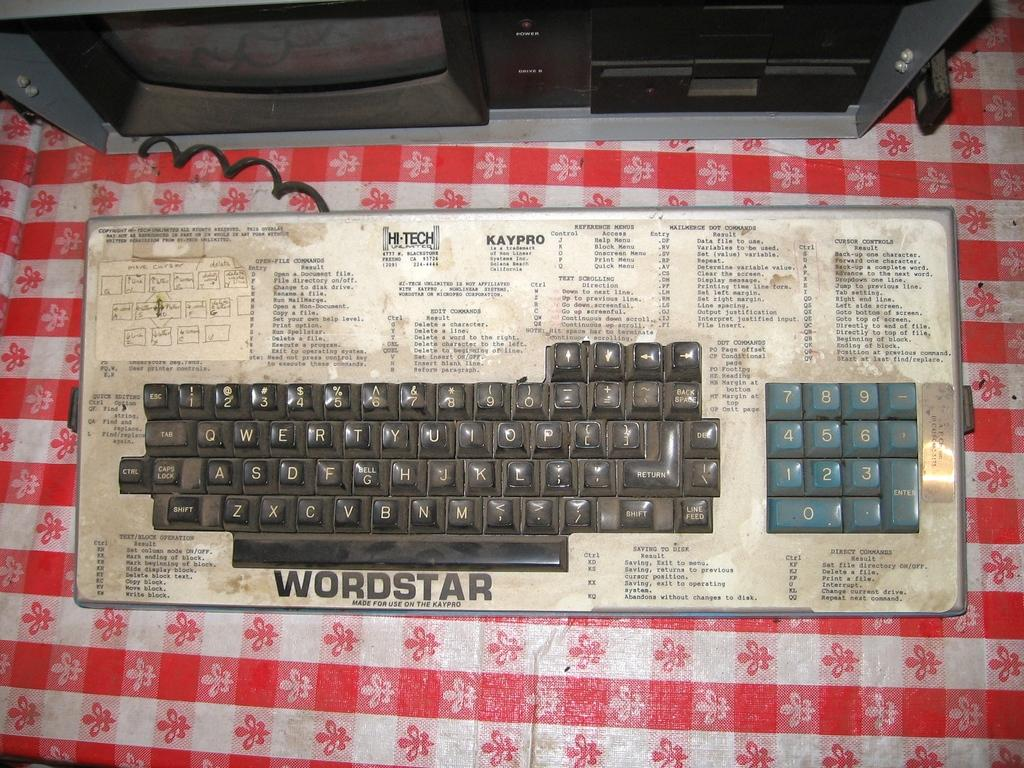<image>
Present a compact description of the photo's key features. A dirty and grimy old keyboard is labeled with the term Wordstar. 